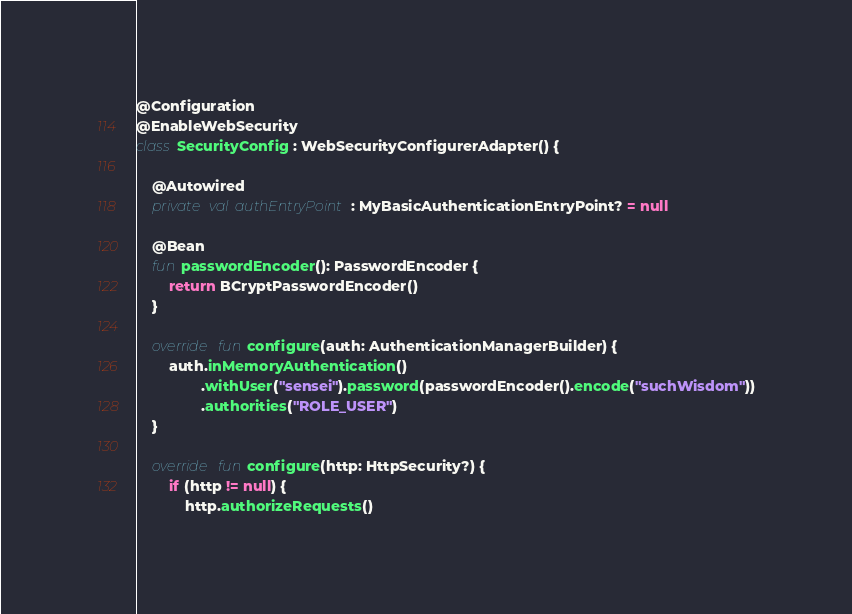<code> <loc_0><loc_0><loc_500><loc_500><_Kotlin_>

@Configuration
@EnableWebSecurity
class SecurityConfig : WebSecurityConfigurerAdapter() {

    @Autowired
    private val authEntryPoint: MyBasicAuthenticationEntryPoint? = null

    @Bean
    fun passwordEncoder(): PasswordEncoder {
        return BCryptPasswordEncoder()
    }

    override fun configure(auth: AuthenticationManagerBuilder) {
        auth.inMemoryAuthentication()
                .withUser("sensei").password(passwordEncoder().encode("suchWisdom"))
                .authorities("ROLE_USER")
    }

    override fun configure(http: HttpSecurity?) {
        if (http != null) {
            http.authorizeRequests()</code> 